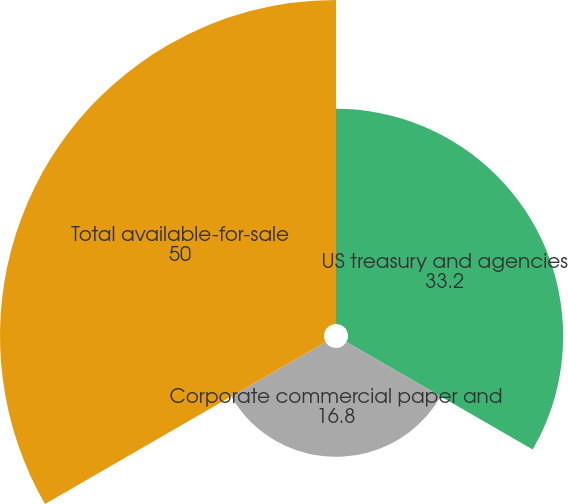Convert chart. <chart><loc_0><loc_0><loc_500><loc_500><pie_chart><fcel>US treasury and agencies<fcel>Corporate commercial paper and<fcel>Total available-for-sale<nl><fcel>33.2%<fcel>16.8%<fcel>50.0%<nl></chart> 